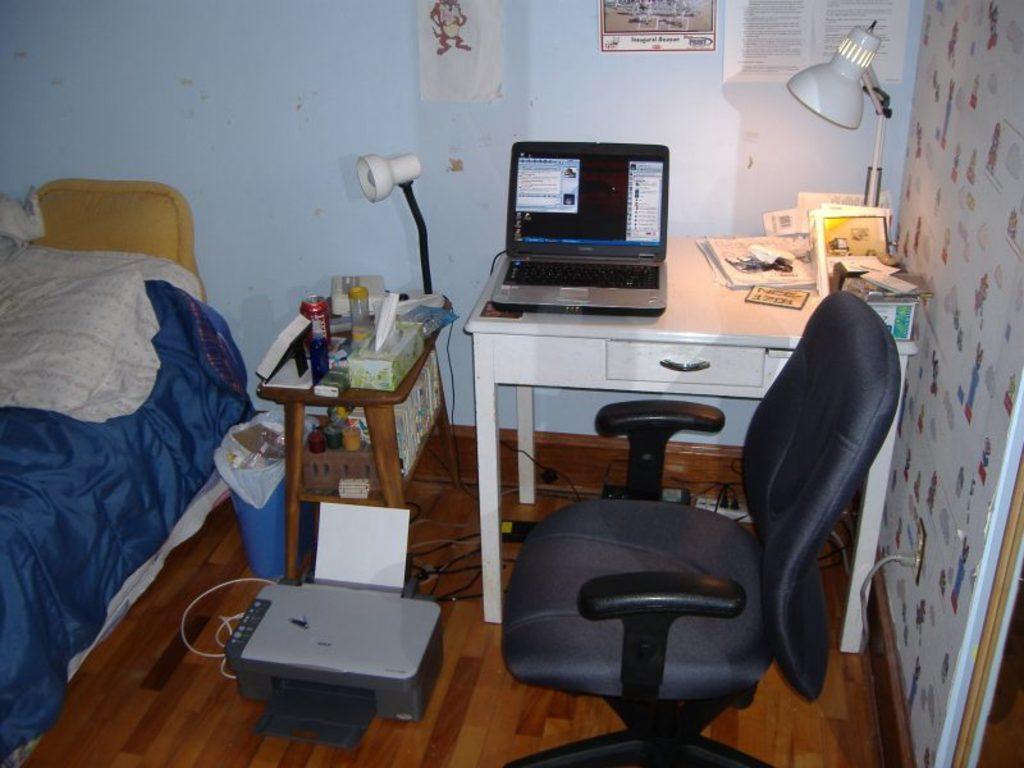Can you describe this image briefly? There is a room. we can see table,chair,cot ,bed and pillow. There is a laptop on a table. 